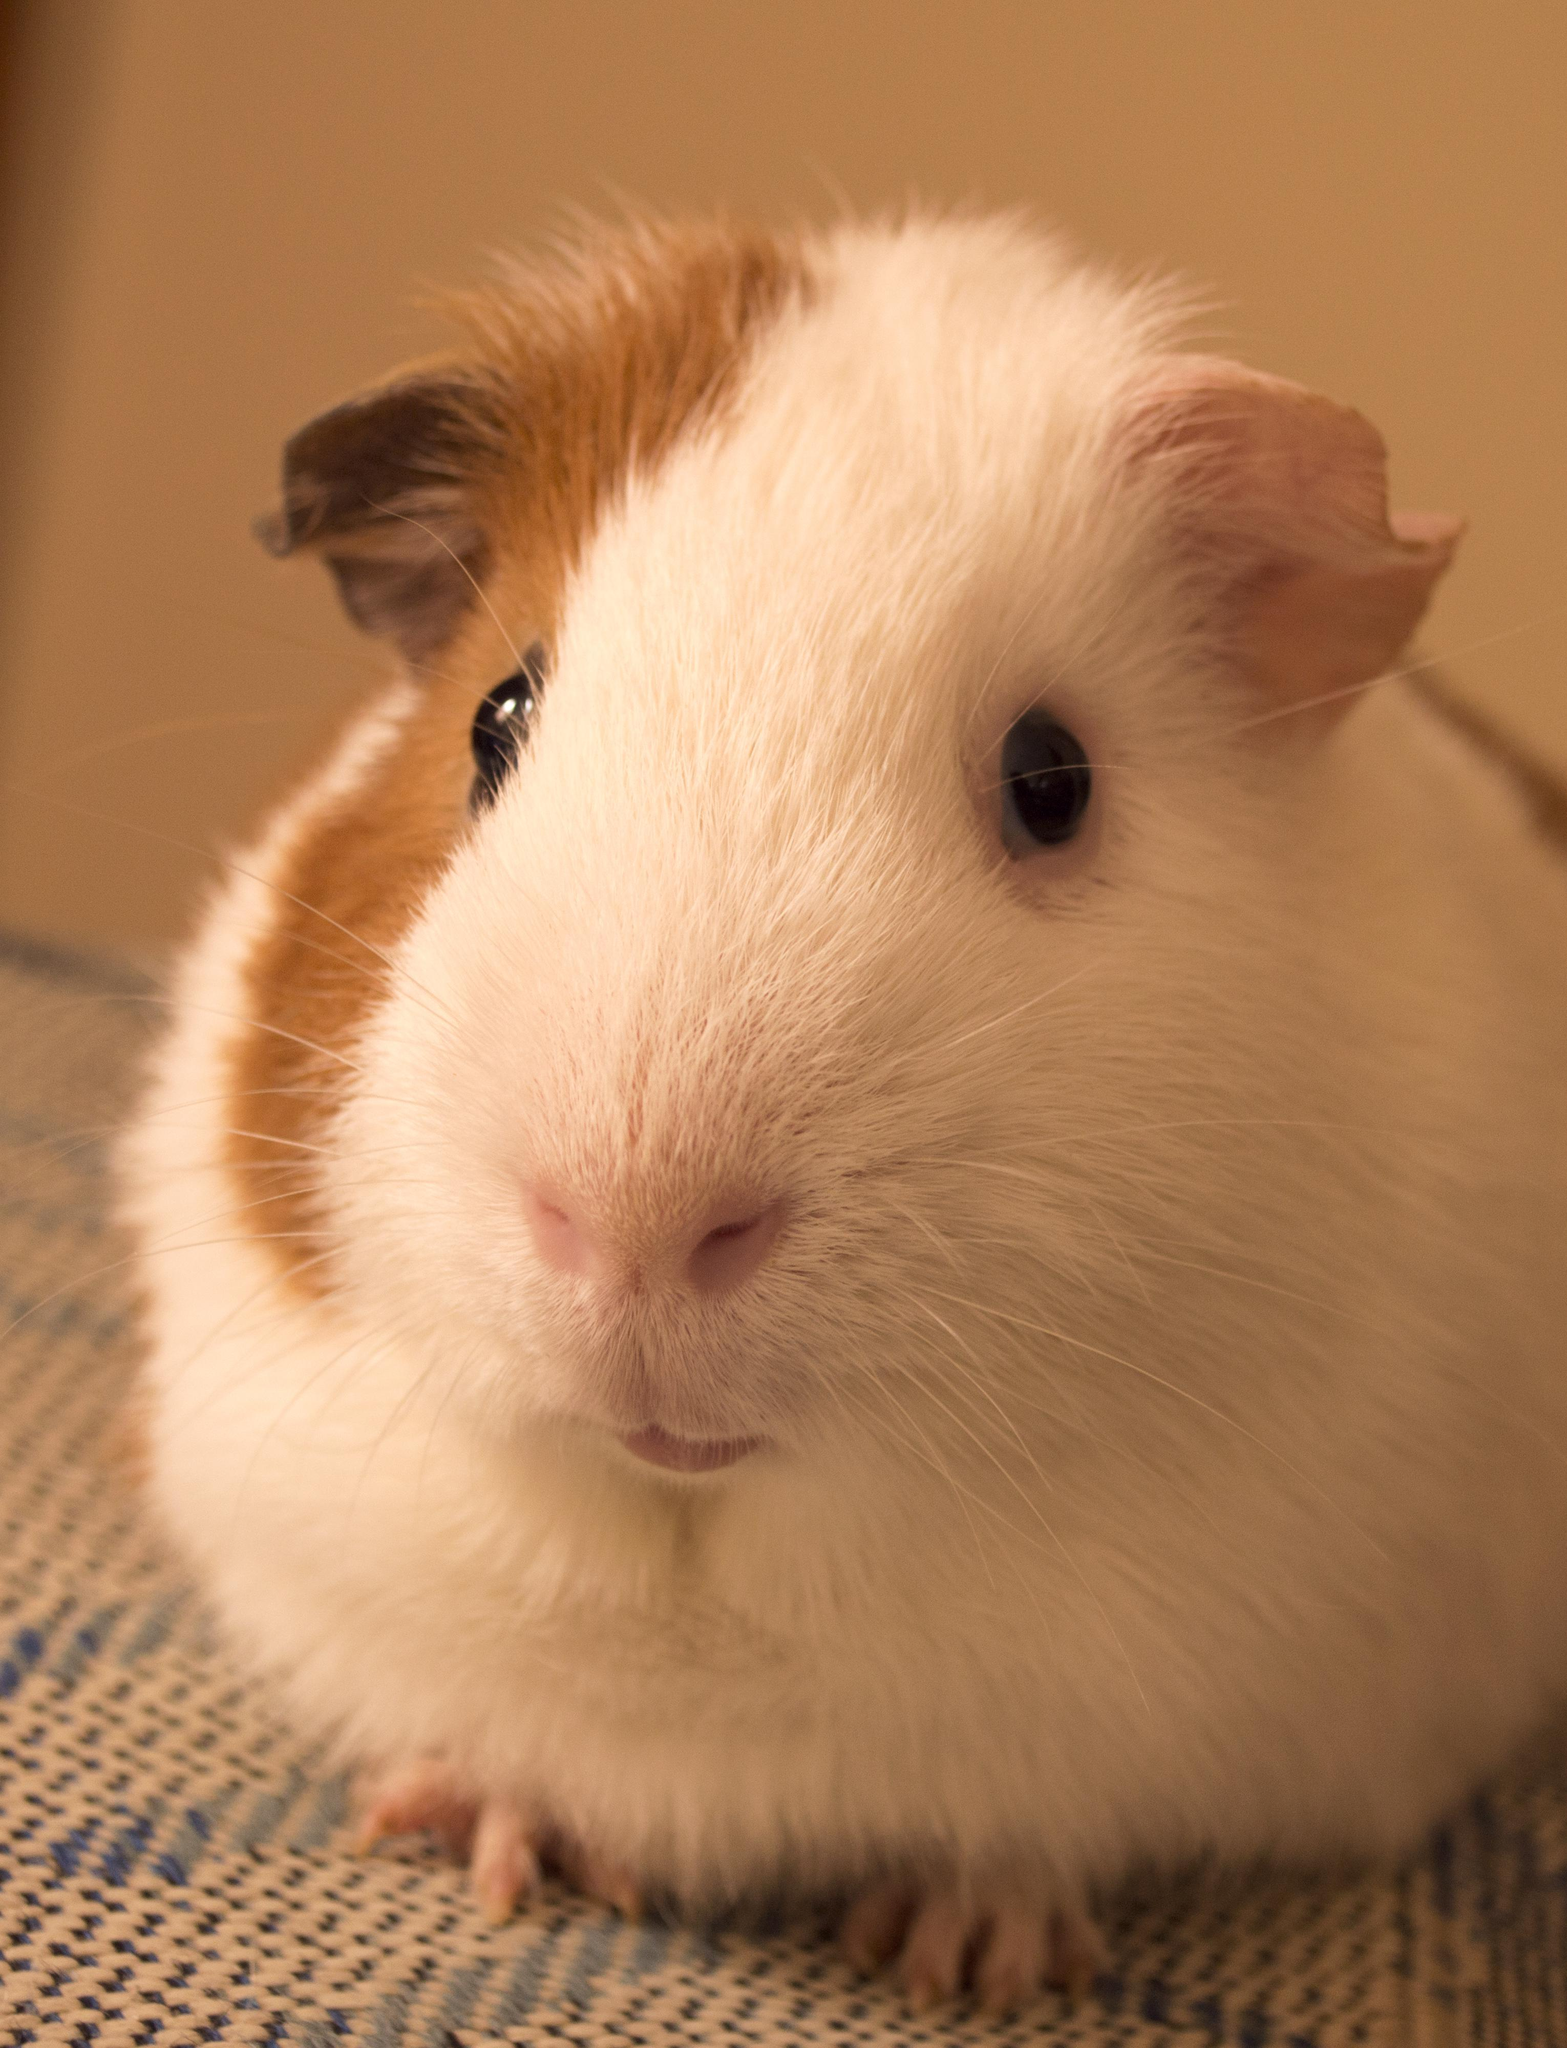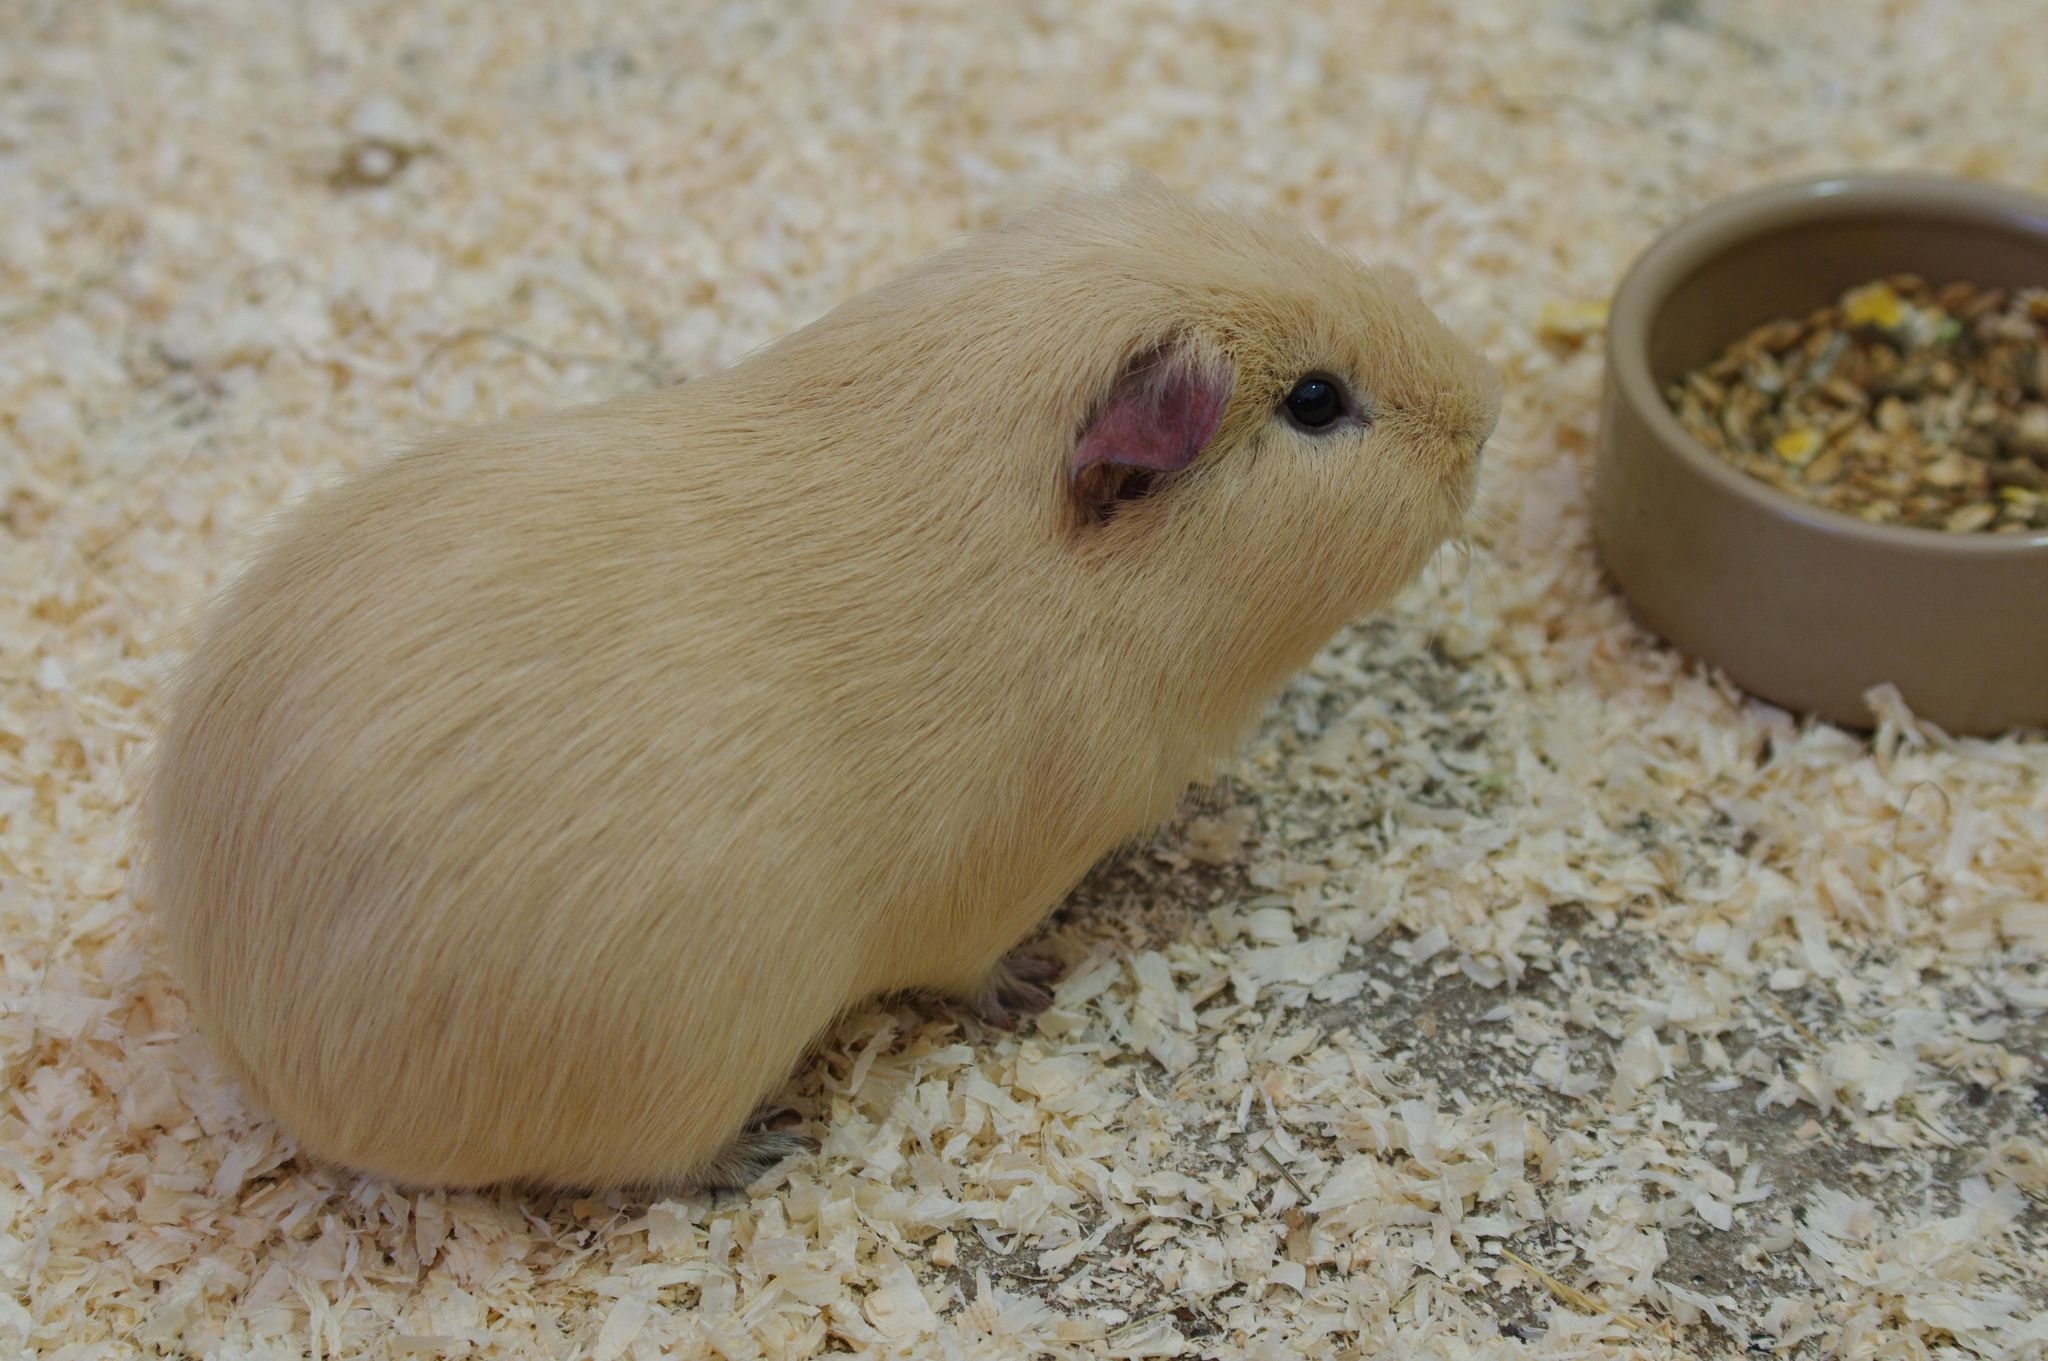The first image is the image on the left, the second image is the image on the right. For the images shown, is this caption "At least one image contains two guinea pigs." true? Answer yes or no. No. 